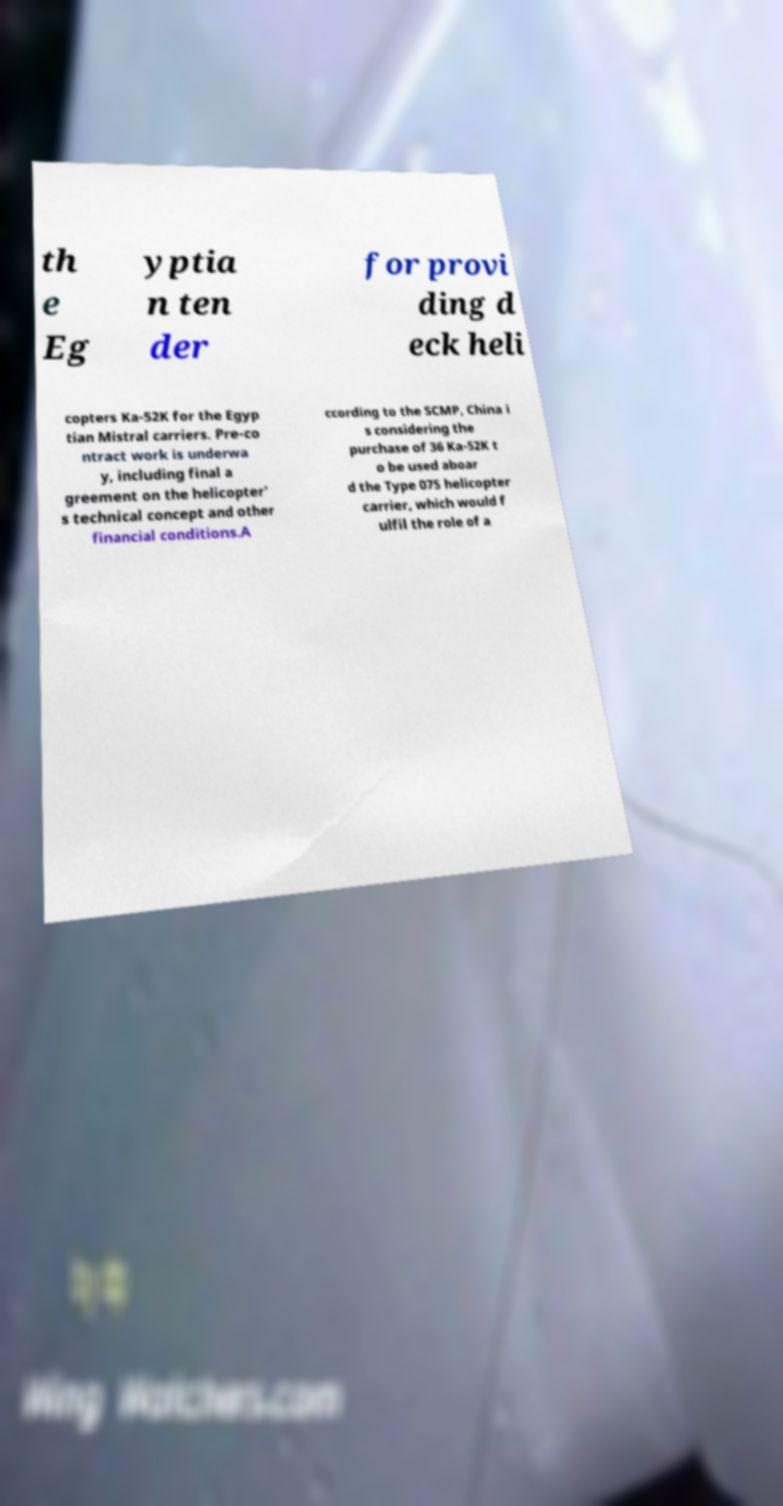Please identify and transcribe the text found in this image. th e Eg yptia n ten der for provi ding d eck heli copters Ka-52K for the Egyp tian Mistral carriers. Pre-co ntract work is underwa y, including final a greement on the helicopter' s technical concept and other financial conditions.A ccording to the SCMP, China i s considering the purchase of 36 Ka-52K t o be used aboar d the Type 075 helicopter carrier, which would f ulfil the role of a 